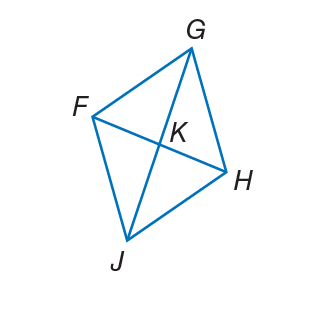Question: The diagonals of rhombus F G H J intersect at K. If m \angle F J H = 82, find m \angle K H J.
Choices:
A. 15
B. 33
C. 49
D. 82
Answer with the letter. Answer: C 